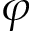<formula> <loc_0><loc_0><loc_500><loc_500>\varphi</formula> 